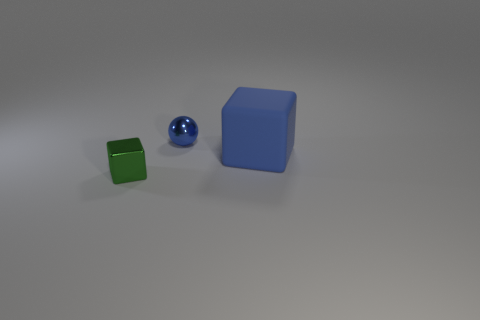Does the matte thing have the same size as the green object?
Make the answer very short. No. What is the shape of the thing that is the same color as the small ball?
Keep it short and to the point. Cube. Is there a object of the same color as the sphere?
Your response must be concise. Yes. What size is the matte cube that is the same color as the metal sphere?
Offer a very short reply. Large. What number of other things are there of the same shape as the blue metal thing?
Your answer should be very brief. 0. What is the size of the blue block?
Provide a short and direct response. Large. What number of objects are either small things or blue objects?
Keep it short and to the point. 3. There is a block that is right of the tiny green cube; what size is it?
Provide a short and direct response. Large. Are there any other things that are the same size as the rubber object?
Your response must be concise. No. What color is the object that is both in front of the tiny blue sphere and to the right of the green metallic thing?
Ensure brevity in your answer.  Blue. 